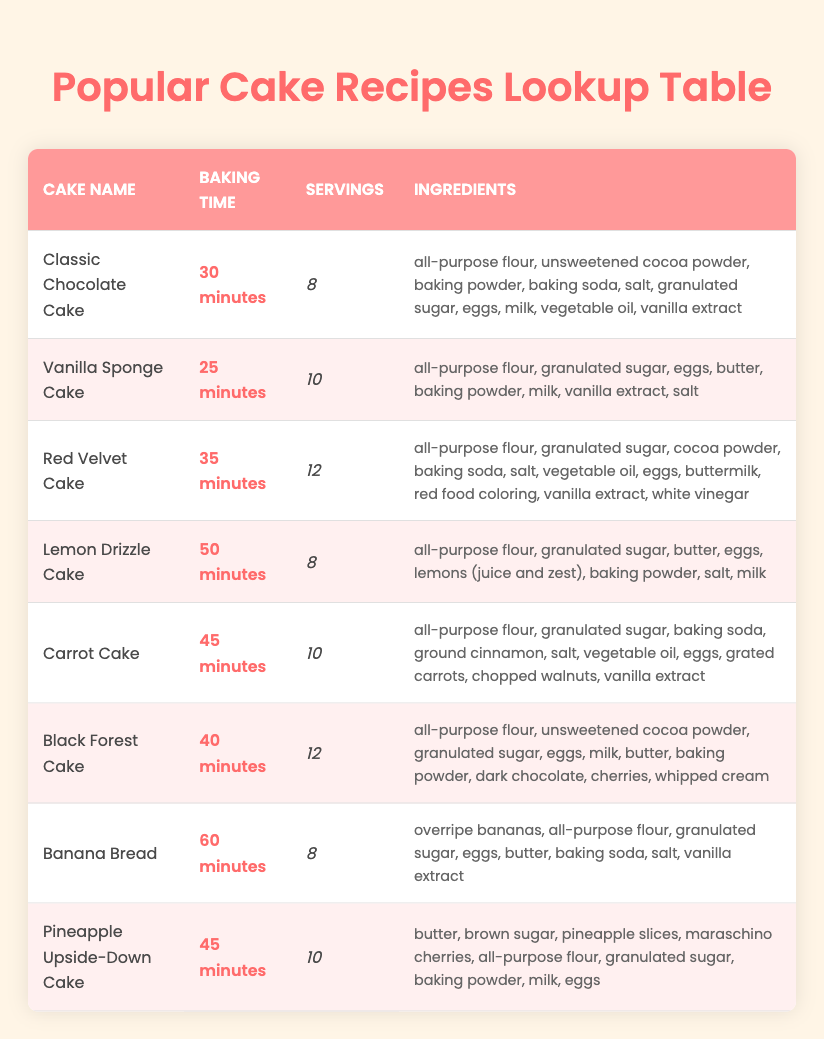What is the baking time for the Classic Chocolate Cake? The table lists "Classic Chocolate Cake" in the first row, where the corresponding baking time is specified as "30 minutes".
Answer: 30 minutes How many servings does the Lemon Drizzle Cake provide? In the table, the Lemon Drizzle Cake is listed under the servings column, which shows it provides "8" servings.
Answer: 8 Which cake has the longest baking time? We can compare all the baking times listed in the table. The longest baking time is for "Banana Bread", which is "60 minutes".
Answer: 60 minutes Is the Red Velvet Cake faster to bake than the Carrot Cake? The baking time for Red Velvet Cake is "35 minutes" and for Carrot Cake, it is "45 minutes". Since 35 is less than 45, Red Velvet Cake is indeed faster.
Answer: Yes What is the average baking time of all the cakes listed? To find the average, sum the baking times: 30 + 25 + 35 + 50 + 45 + 40 + 60 + 45 = 330 minutes. There are 8 cakes, so the average is 330/8 = 41.25 minutes.
Answer: 41.25 minutes Does the Black Forest Cake require more ingredients than the Vanilla Sponge Cake? Counting the ingredients, Black Forest Cake has "10" ingredients while Vanilla Sponge Cake has "8". Thus, Black Forest Cake has more ingredients.
Answer: Yes How many more servings does the Red Velvet Cake offer compared to the Classic Chocolate Cake? Red Velvet Cake serves "12" while Classic Chocolate Cake serves "8". The difference is 12 - 8 = 4 servings.
Answer: 4 servings Which cakes have a baking time of 45 minutes? The table mentions two cakes with a baking time of 45 minutes: "Carrot Cake" and "Pineapple Upside-Down Cake".
Answer: Carrot Cake, Pineapple Upside-Down Cake What percentage of cakes have a baking time longer than 40 minutes? There are 8 cakes in total, and 4 of them (Banana Bread, Lemon Drizzle Cake, Carrot Cake, and Pineapple Upside-Down Cake) have baking times longer than 40 minutes. Therefore, the percentage is (4/8) * 100 = 50%.
Answer: 50% 